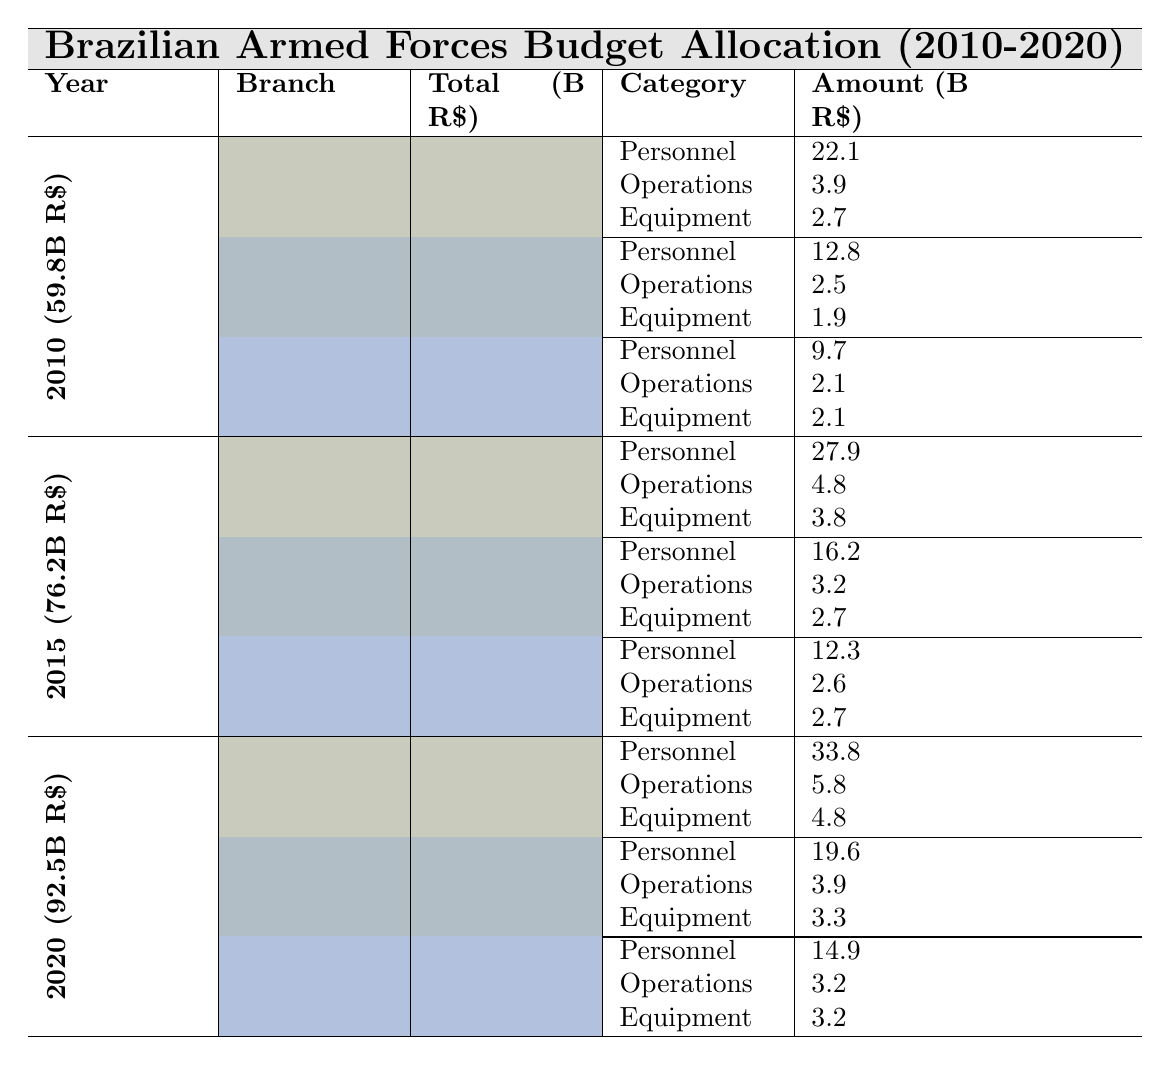What was the total budget allocation for the Army in 2015? In 2015, the budget allocation for the Army was specifically listed in the table, which shows it as 36.5 billion R$.
Answer: 36.5 billion R$ What was the total budget of the Brazilian Armed Forces in 2020? The table clearly indicates that the total budget for the Brazilian Armed Forces in 2020 was 92.5 billion R$.
Answer: 92.5 billion R$ How much was allocated to Operations by the Navy in 2010? Referring to the table, the Navy's budget allocation for Operations in 2010 was 2.5 billion R$.
Answer: 2.5 billion R$ What was the percentage of the total budget allocated to the Air Force in 2010? The Air Force allocation in 2010 was 13.9 billion R$, and the total budget was 59.8 billion R$. Calculating the percentage: (13.9 / 59.8) * 100 = 23.26%.
Answer: 23.26% Did the personnel expenditure for the Air Force increase from 2015 to 2020? In 2015, the personnel expenditure for the Air Force was 12.3 billion R$, and in 2020, it was 14.9 billion R$. Since 14.9 is greater than 12.3, the expenditure increased.
Answer: Yes What was the combined expenditure on Personnel for all branches in 2015? The Personnel expenditure for each branch in 2015 was: Army 27.9 billion R$, Navy 16.2 billion R$, and Air Force 12.3 billion R$. Adding these amounts: 27.9 + 16.2 + 12.3 = 56.4 billion R$.
Answer: 56.4 billion R$ How much more was spent on Personnel in 2020 compared to 2010 for the Army? The Army spent 33.8 billion R$ on Personnel in 2020 and 22.1 billion R$ in 2010. The difference is: 33.8 - 22.1 = 11.7 billion R$.
Answer: 11.7 billion R$ Which branch had the highest equipment expenditure in 2020? Referring to the table, in 2020 the Army had 4.8 billion R$, the Navy had 3.3 billion R$, and the Air Force had 3.2 billion R$ on equipment. Since 4.8 is the highest, the Army had the highest equipment expenditure.
Answer: Army What was the average equipment expenditure per branch in 2015? In 2015, the equipment expenditures were: Army 3.8 billion R$, Navy 2.7 billion R$, and Air Force 2.7 billion R$. The average is calculated as: (3.8 + 2.7 + 2.7) / 3 = 3.06667 billion R$, approximately.
Answer: 3.07 billion R$ Is it true that the total budget for the Brazilian Armed Forces increased each consecutive year from 2010 to 2020? Looking at the total budgets: 2010 was 59.8 billion R$, 2015 was 76.2 billion R$, and 2020 was 92.5 billion R$. Since each value is higher than the previous one, it is true that the total budget increased every year.
Answer: Yes 